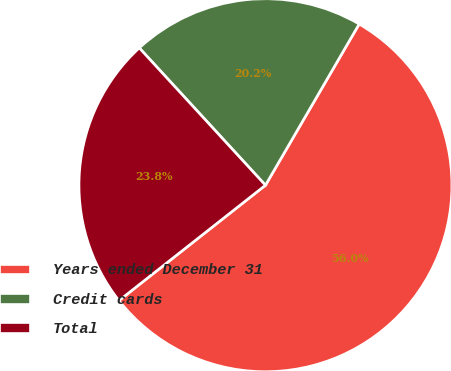Convert chart to OTSL. <chart><loc_0><loc_0><loc_500><loc_500><pie_chart><fcel>Years ended December 31<fcel>Credit cards<fcel>Total<nl><fcel>56.01%<fcel>20.21%<fcel>23.79%<nl></chart> 